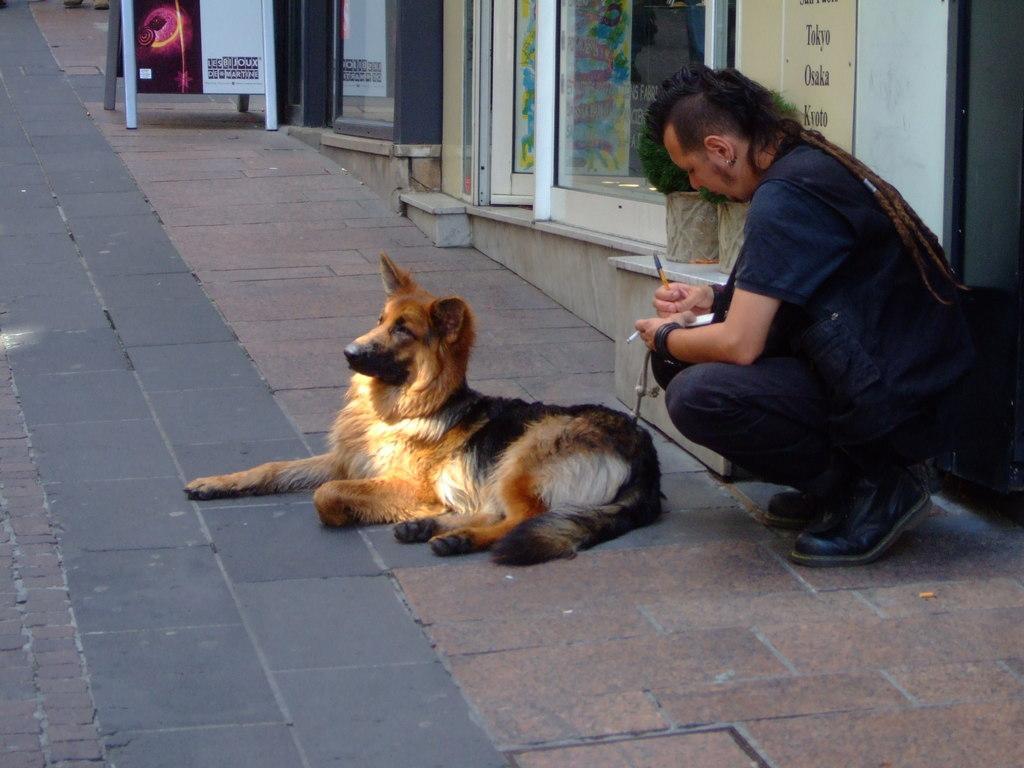In one or two sentences, can you explain what this image depicts? This picture is taken on the pavement of a city. In the center of the picture there is a dog, to the right side of the picture there is a man. The man is wearing a blue color shirt. In the background of the image there are doors, windows, and a hoarding. This man is writing something in the notes. 